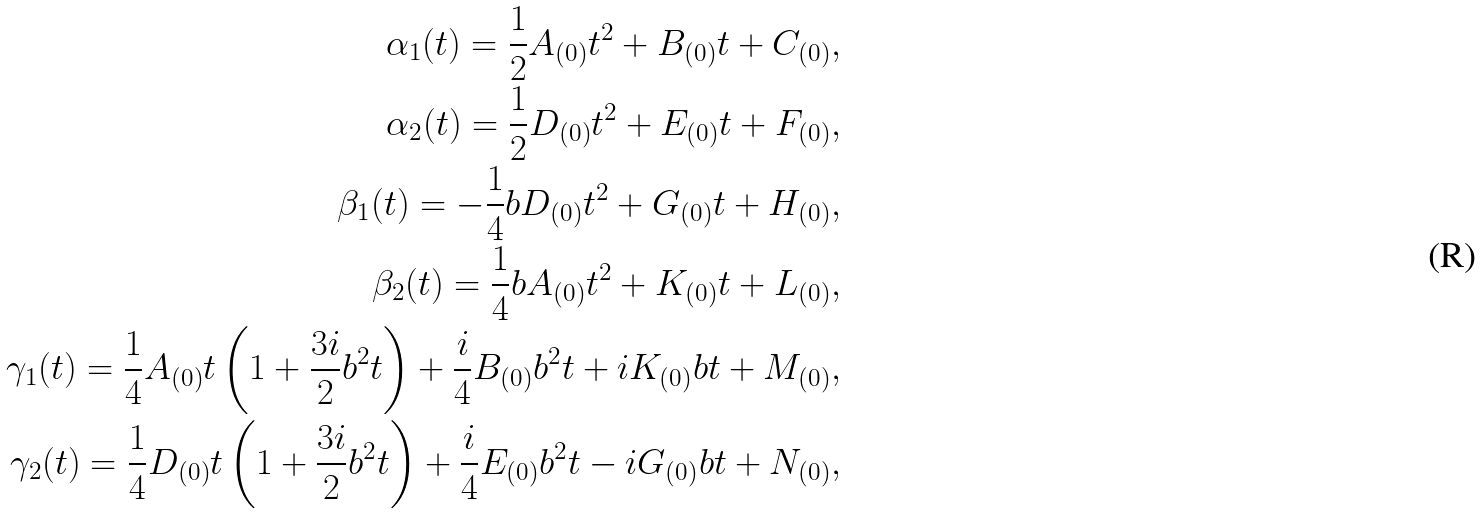<formula> <loc_0><loc_0><loc_500><loc_500>\alpha _ { 1 } ( t ) = \frac { 1 } { 2 } A _ { ( 0 ) } t ^ { 2 } + B _ { ( 0 ) } t + C _ { ( 0 ) } , \\ \alpha _ { 2 } ( t ) = \frac { 1 } { 2 } D _ { ( 0 ) } t ^ { 2 } + E _ { ( 0 ) } t + F _ { ( 0 ) } , \\ \beta _ { 1 } ( t ) = - \frac { 1 } { 4 } b D _ { ( 0 ) } t ^ { 2 } + G _ { ( 0 ) } t + H _ { ( 0 ) } , \\ \beta _ { 2 } ( t ) = \frac { 1 } { 4 } b A _ { ( 0 ) } t ^ { 2 } + K _ { ( 0 ) } t + L _ { ( 0 ) } , \\ \gamma _ { 1 } ( t ) = \frac { 1 } { 4 } A _ { ( 0 ) } t \left ( 1 + \frac { 3 i } { 2 } b ^ { 2 } t \right ) + \frac { i } { 4 } B _ { ( 0 ) } b ^ { 2 } t + i K _ { ( 0 ) } b t + M _ { ( 0 ) } , \\ \gamma _ { 2 } ( t ) = \frac { 1 } { 4 } D _ { ( 0 ) } t \left ( 1 + \frac { 3 i } { 2 } b ^ { 2 } t \right ) + \frac { i } { 4 } E _ { ( 0 ) } b ^ { 2 } t - i G _ { ( 0 ) } b t + N _ { ( 0 ) } ,</formula> 